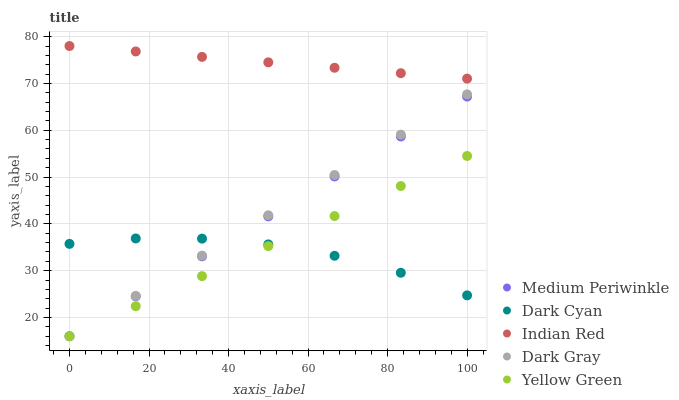Does Dark Cyan have the minimum area under the curve?
Answer yes or no. Yes. Does Indian Red have the maximum area under the curve?
Answer yes or no. Yes. Does Dark Gray have the minimum area under the curve?
Answer yes or no. No. Does Dark Gray have the maximum area under the curve?
Answer yes or no. No. Is Medium Periwinkle the smoothest?
Answer yes or no. Yes. Is Dark Cyan the roughest?
Answer yes or no. Yes. Is Dark Gray the smoothest?
Answer yes or no. No. Is Dark Gray the roughest?
Answer yes or no. No. Does Dark Gray have the lowest value?
Answer yes or no. Yes. Does Indian Red have the lowest value?
Answer yes or no. No. Does Indian Red have the highest value?
Answer yes or no. Yes. Does Dark Gray have the highest value?
Answer yes or no. No. Is Medium Periwinkle less than Indian Red?
Answer yes or no. Yes. Is Indian Red greater than Yellow Green?
Answer yes or no. Yes. Does Medium Periwinkle intersect Dark Cyan?
Answer yes or no. Yes. Is Medium Periwinkle less than Dark Cyan?
Answer yes or no. No. Is Medium Periwinkle greater than Dark Cyan?
Answer yes or no. No. Does Medium Periwinkle intersect Indian Red?
Answer yes or no. No. 